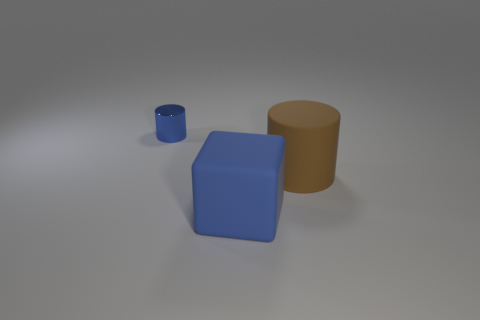Can this image be used to explain any concepts in geometry? Absolutely, this image can be used to demonstrate basic geometric shapes and the concept of three-dimensional objects. For instance, it's an excellent visual aid for discussing the properties of cylinders and cubes, such as vertices, edges, faces, and symmetry. 